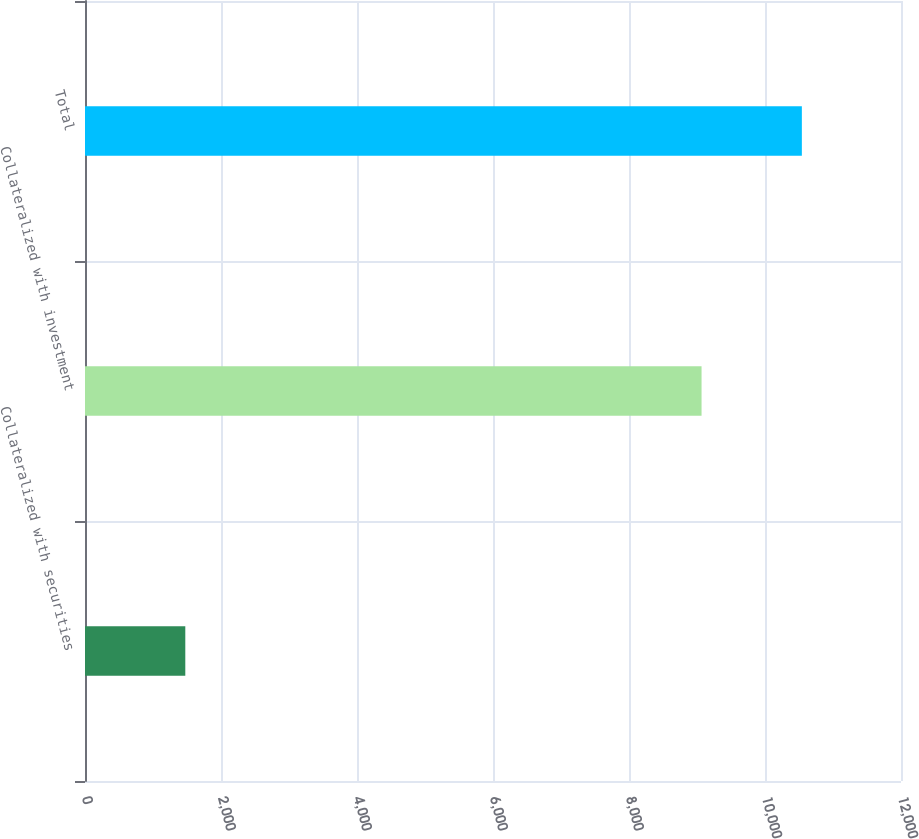Convert chart. <chart><loc_0><loc_0><loc_500><loc_500><bar_chart><fcel>Collateralized with securities<fcel>Collateralized with investment<fcel>Total<nl><fcel>1475<fcel>9067<fcel>10542<nl></chart> 